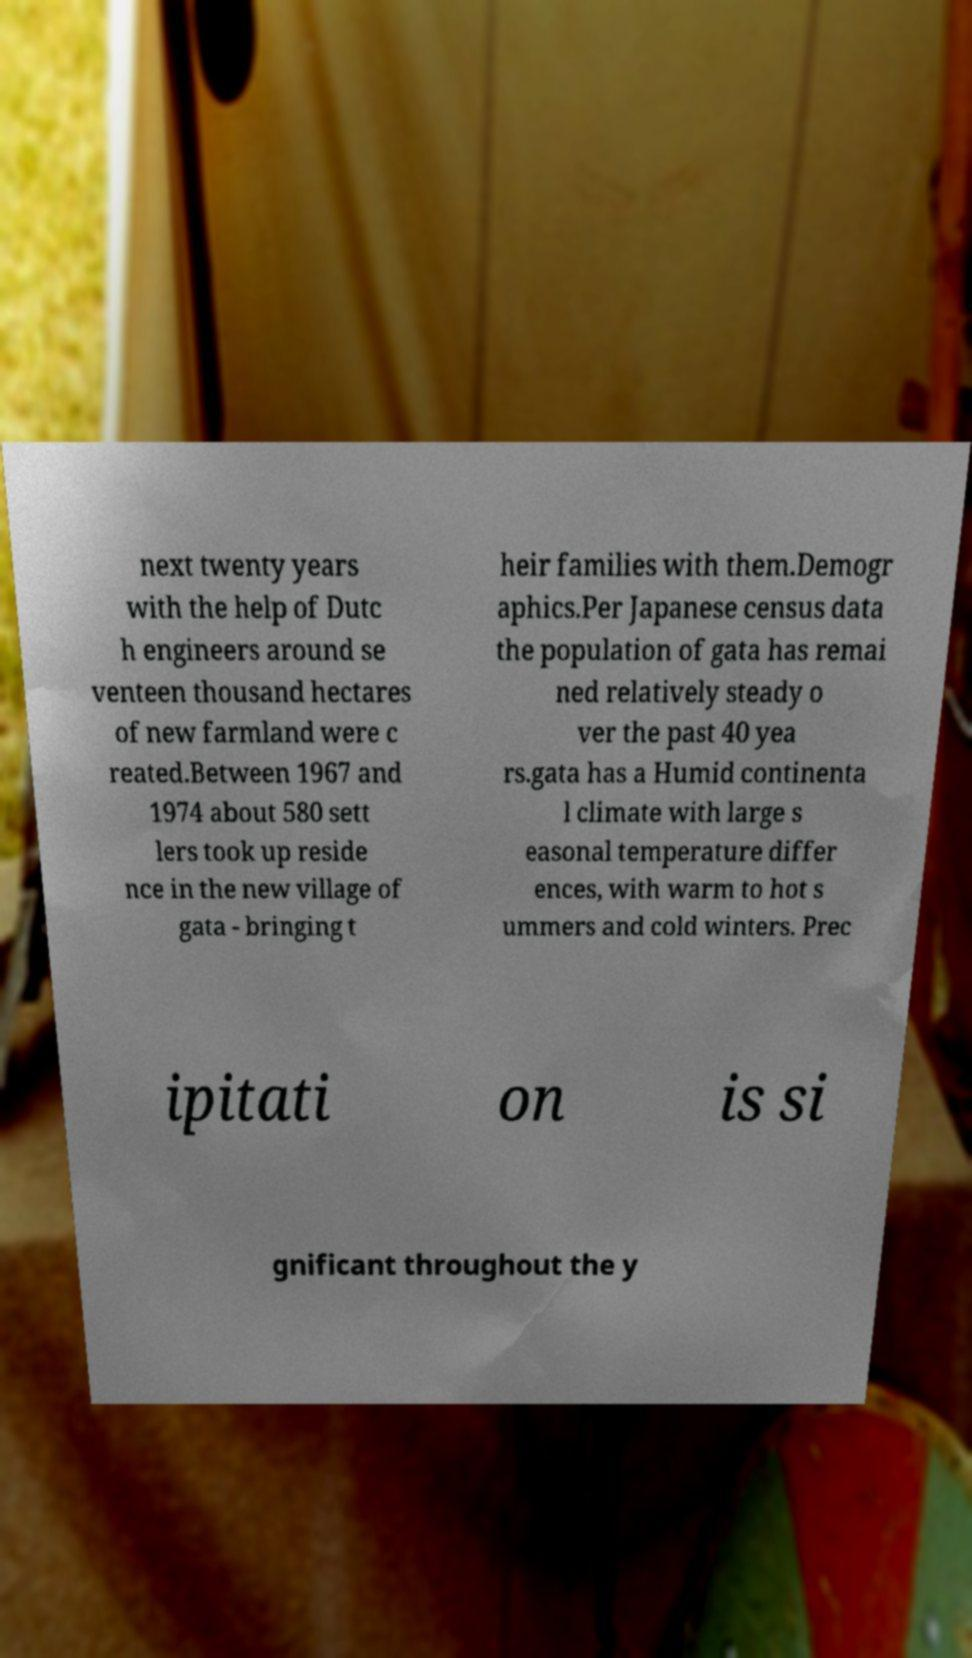For documentation purposes, I need the text within this image transcribed. Could you provide that? next twenty years with the help of Dutc h engineers around se venteen thousand hectares of new farmland were c reated.Between 1967 and 1974 about 580 sett lers took up reside nce in the new village of gata - bringing t heir families with them.Demogr aphics.Per Japanese census data the population of gata has remai ned relatively steady o ver the past 40 yea rs.gata has a Humid continenta l climate with large s easonal temperature differ ences, with warm to hot s ummers and cold winters. Prec ipitati on is si gnificant throughout the y 